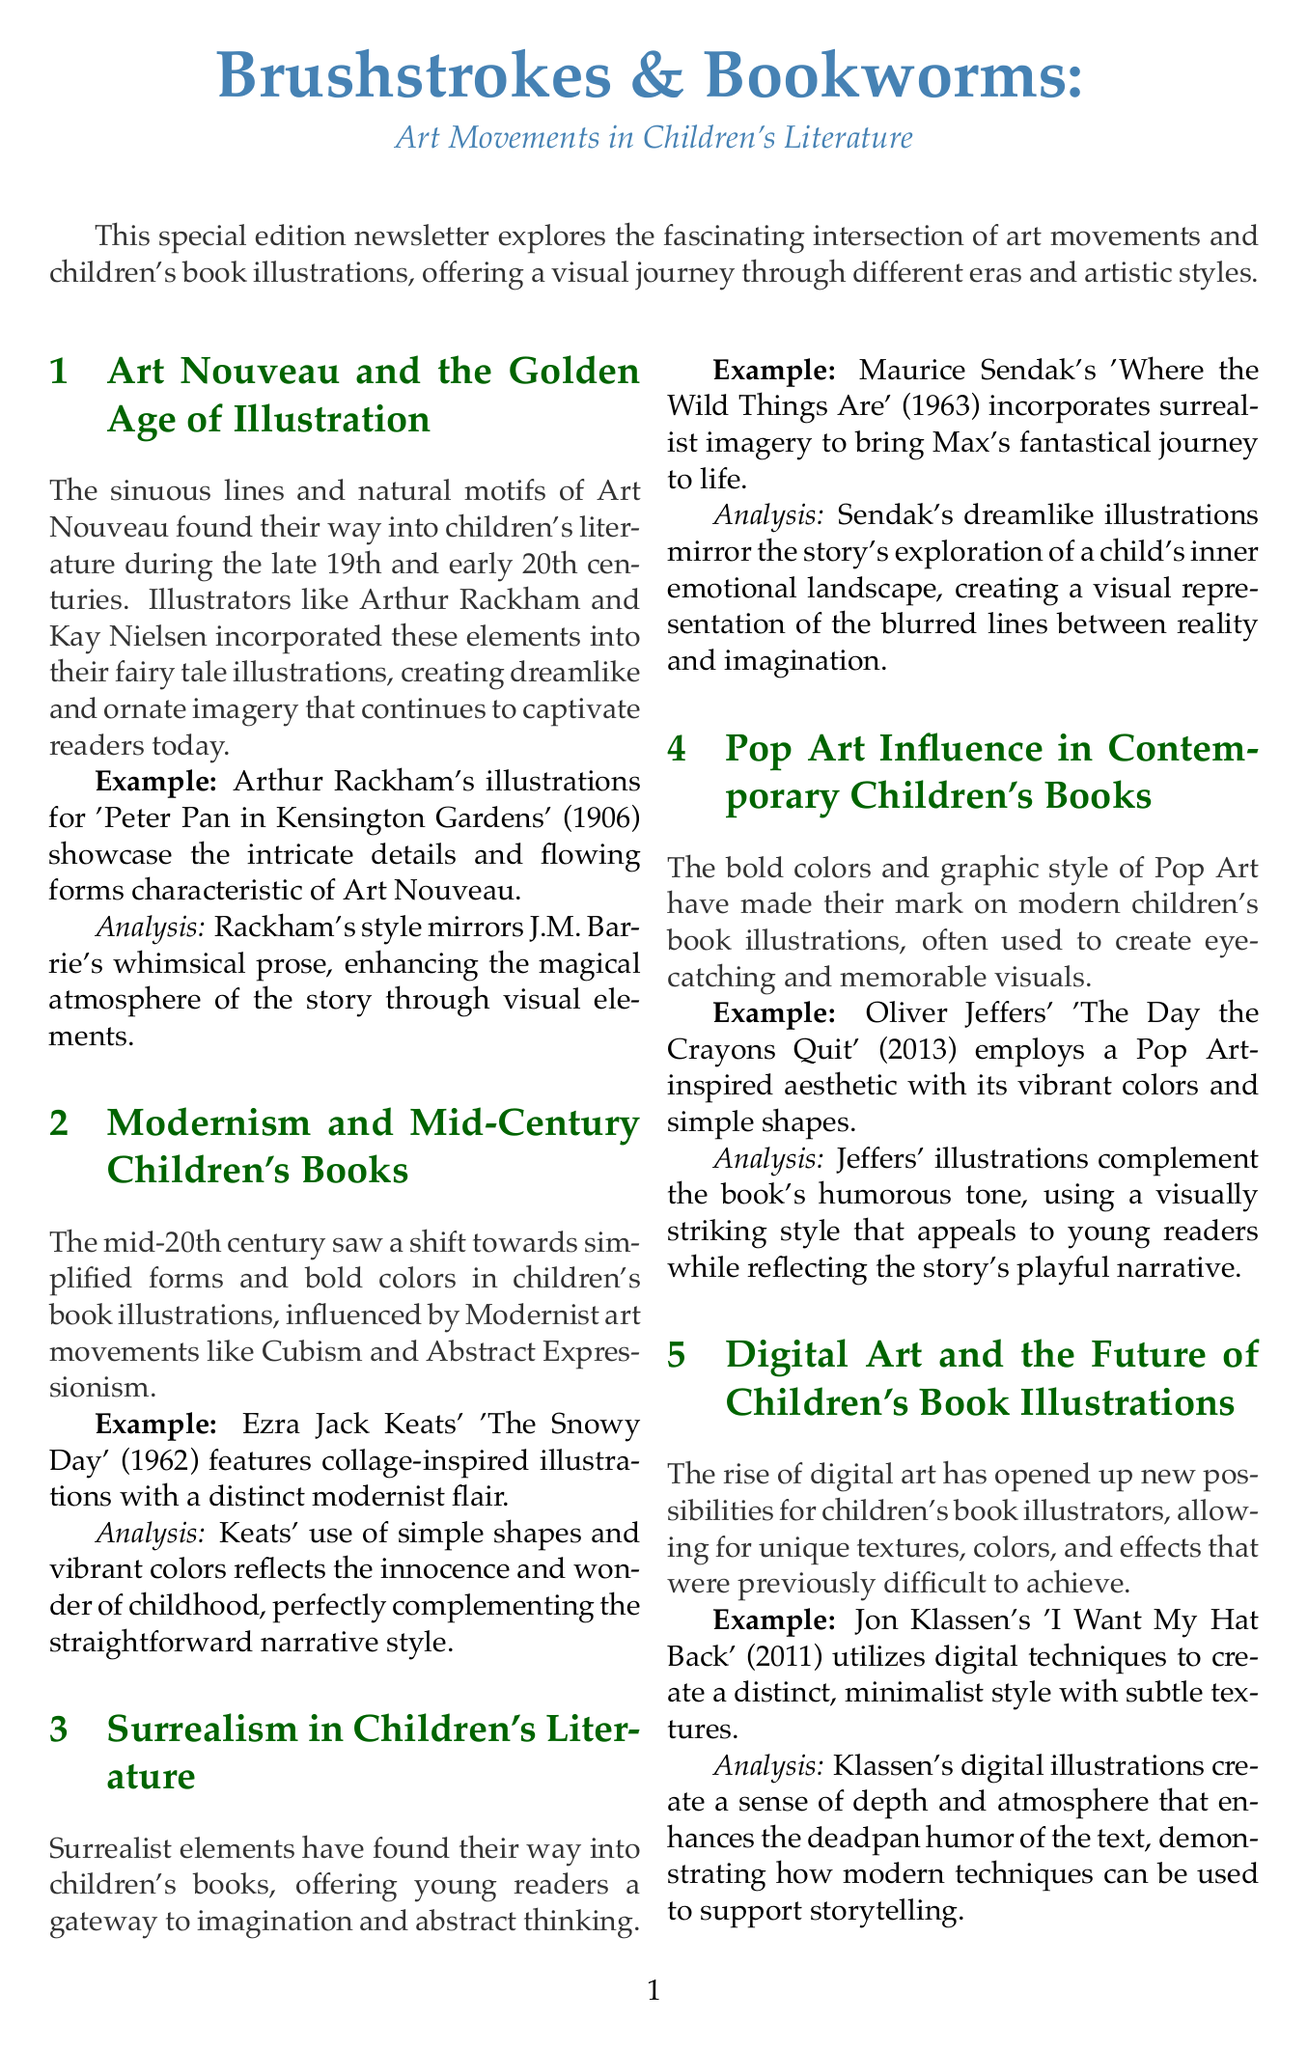what is the title of the newsletter? The title is mentioned at the top of the newsletter.
Answer: Brushstrokes & Bookworms: Art Movements in Children's Literature who is the author of 'Peter Pan in Kensington Gardens'? The example provided relates to Arthur Rackham's illustrations for this book.
Answer: Arthur Rackham what year was 'The Snowy Day' published? The publication year of this book is listed in the examples section.
Answer: 1962 which art movement influenced Maurice Sendak's illustrations? The section discusses the influence of different art movements on children's illustrations.
Answer: Surrealism what style does Jon Klassen's 'I Want My Hat Back' utilize? This information is specified in the digital art section of the newsletter.
Answer: Digital techniques how do Ezra Jack Keats' illustrations reflect childhood? The analysis explains the relationship between the illustrations and childhood.
Answer: Innocence and wonder what is the conclusion of the newsletter about art movements? The conclusion summarizes the overall impact of art movements discussed in the newsletter.
Answer: Profoundly influenced children's book illustrations which author wrote 'Where the Wild Things Are'? This book's example is attributed to Maurice Sendak within the newsletter.
Answer: Maurice Sendak what is one of the recommended further reading titles? The document lists a few titles for further reading at the end.
Answer: The Art of Children's Picture Books: A Critical Survey by Sylvia S. Marantz 